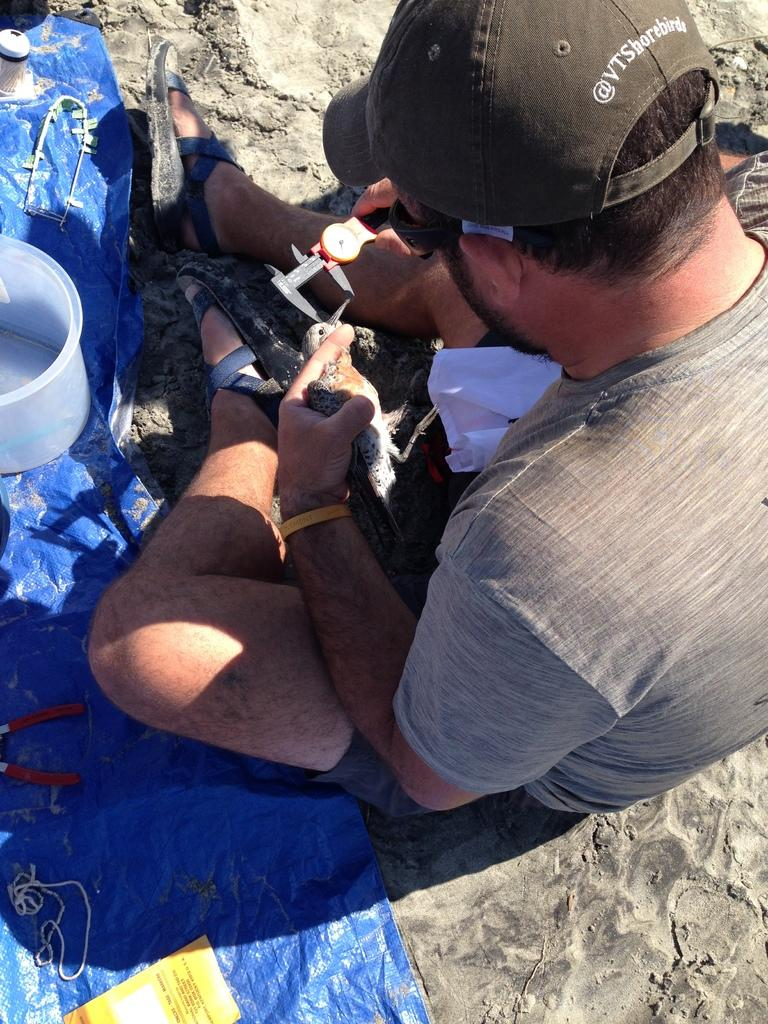What is the person in the image doing? The person is sitting in the image. What color is the shirt the person is wearing? The person is wearing a gray shirt. What type of headwear is the person wearing? The person is wearing a brown cap. What is the person holding in the image? The person is holding an object. What color is the cover in front of the person? The cover in front of the person is blue. How many sisters does the person in the image have? There is no information about the person's sisters in the image, so it cannot be determined. 